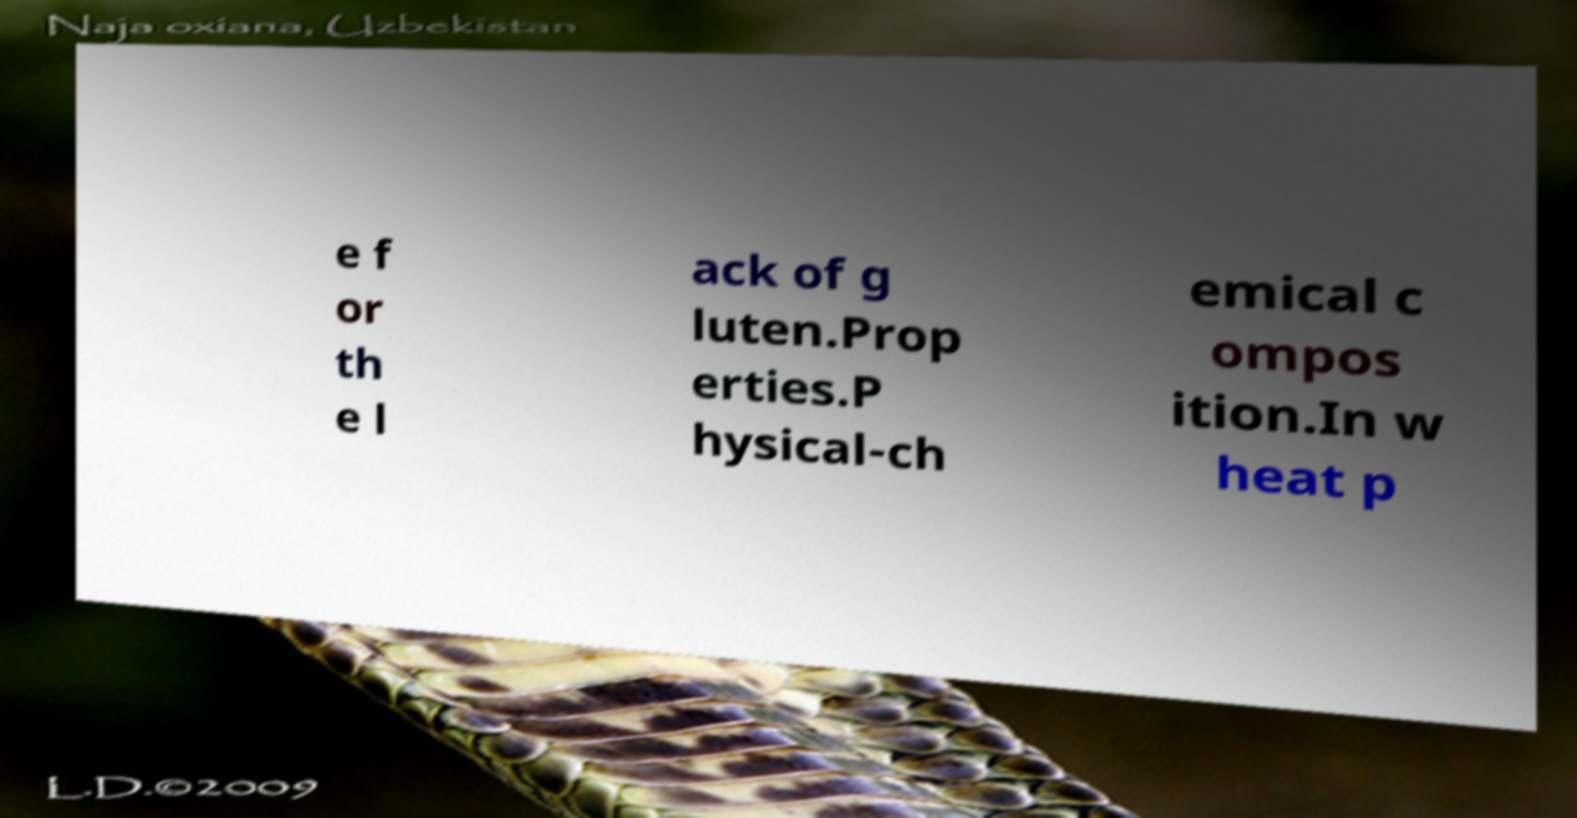There's text embedded in this image that I need extracted. Can you transcribe it verbatim? e f or th e l ack of g luten.Prop erties.P hysical-ch emical c ompos ition.In w heat p 